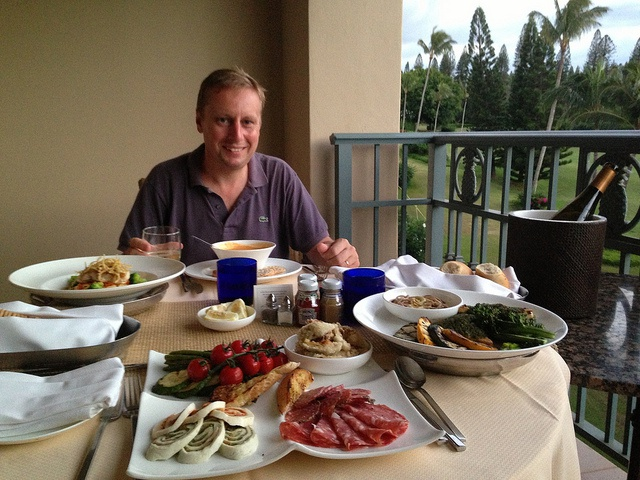Describe the objects in this image and their specific colors. I can see dining table in olive, darkgray, black, lightgray, and gray tones, people in olive, black, maroon, brown, and gray tones, bowl in olive, black, gray, darkgray, and lightgray tones, bowl in olive, lightgray, black, darkgray, and gray tones, and bowl in olive, darkgray, maroon, and tan tones in this image. 